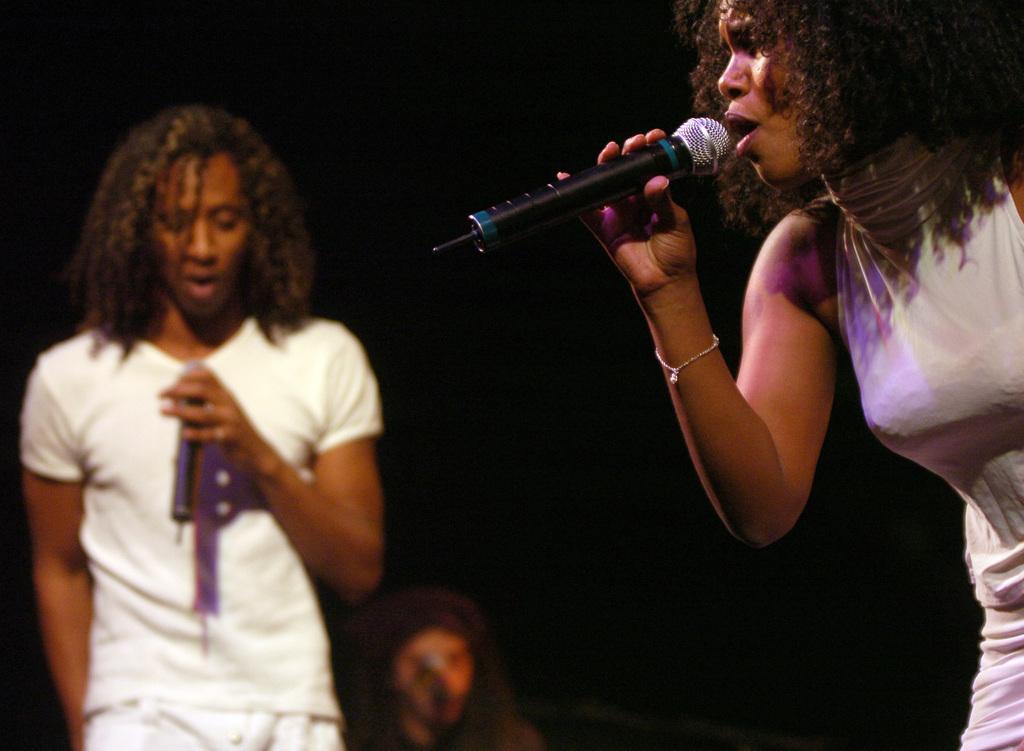Please provide a concise description of this image. This image might be clicked in a musical concert. There are three people in this image,on the right side there is a woman she is wearing white color dress, she is having bracelet to her hand ,she is holding a mike and singing something. On the left side there is a man and he is wearing white color dress. He is holding Mike and singing something. Behind him there is a man. 